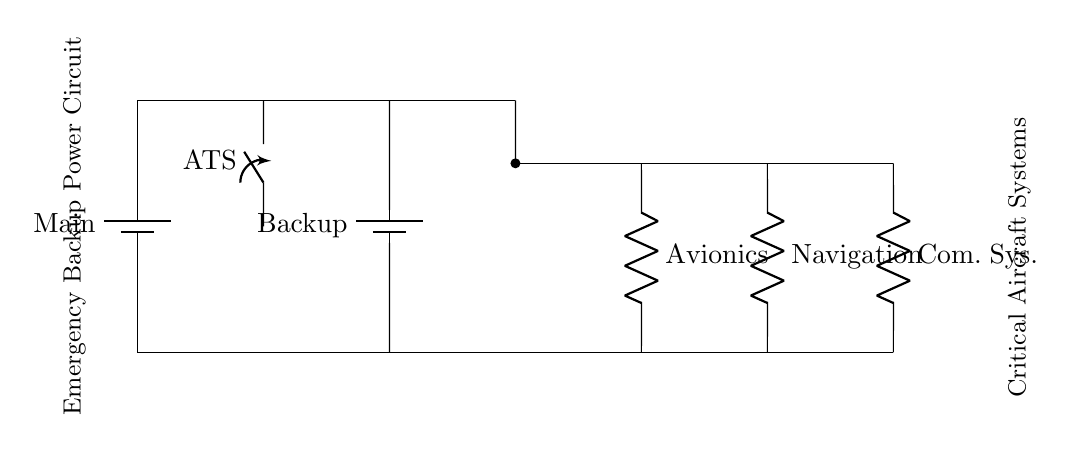What type of switch is depicted in this circuit? The circuit includes a single-pole single-throw switch labeled as ATS, which stands for Automatic Transfer Switch. This allows for manual or automatic switching between power sources.
Answer: Automatic Transfer Switch How many critical systems are connected to the distribution bus? There are three distinct critical systems connected to the distribution bus, as indicated by the three resistors labeled Avionics, Navigation, and Communication System.
Answer: Three What is the purpose of the backup generator in this circuit? The backup generator acts as an alternative power source in case the main power supply fails, ensuring that critical systems continue to operate during an emergency.
Answer: Alternative power source Which component indicates the main power supply in the circuit? The component labeled as Main, a battery symbol, represents the primary source of electricity for the circuit, providing continuous power under normal conditions.
Answer: Main battery What happens if the main power supply fails? If the main power supply fails, the Automatic Transfer Switch will redirect the power supply from the backup generator. This mechanism ensures that critical systems continue to receive power without interruption.
Answer: Power redirection What is the function of the distribution bus in this emergency backup circuit? The distribution bus serves as a central point where power from either the main supply or backup generator is distributed to the connected critical systems, allowing for efficient power management.
Answer: Central power distribution What type of system does the ATS switch connect to, based on the circuit? The ATS switch connects to both the main power supply and the backup generator, illustrating its role in managing power sources for critical aircraft systems.
Answer: Power management system 